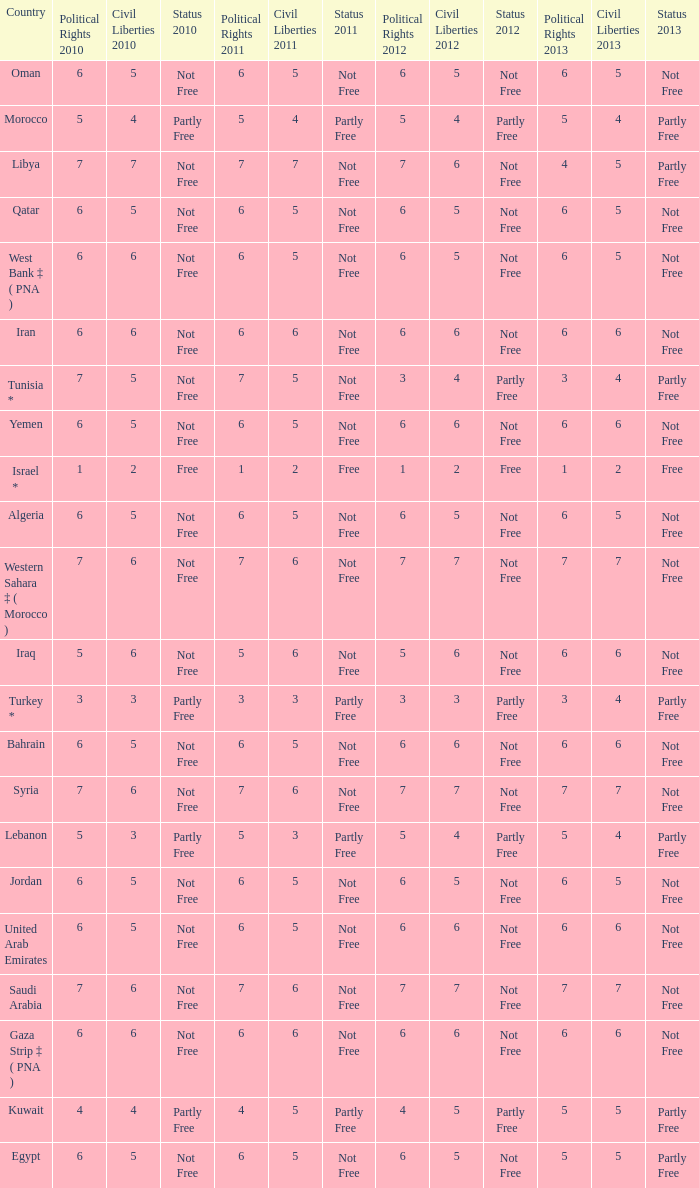How many civil liberties 2013 values are associated with a 2010 political rights value of 6, civil liberties 2012 values over 5, and political rights 2011 under 6? 0.0. 